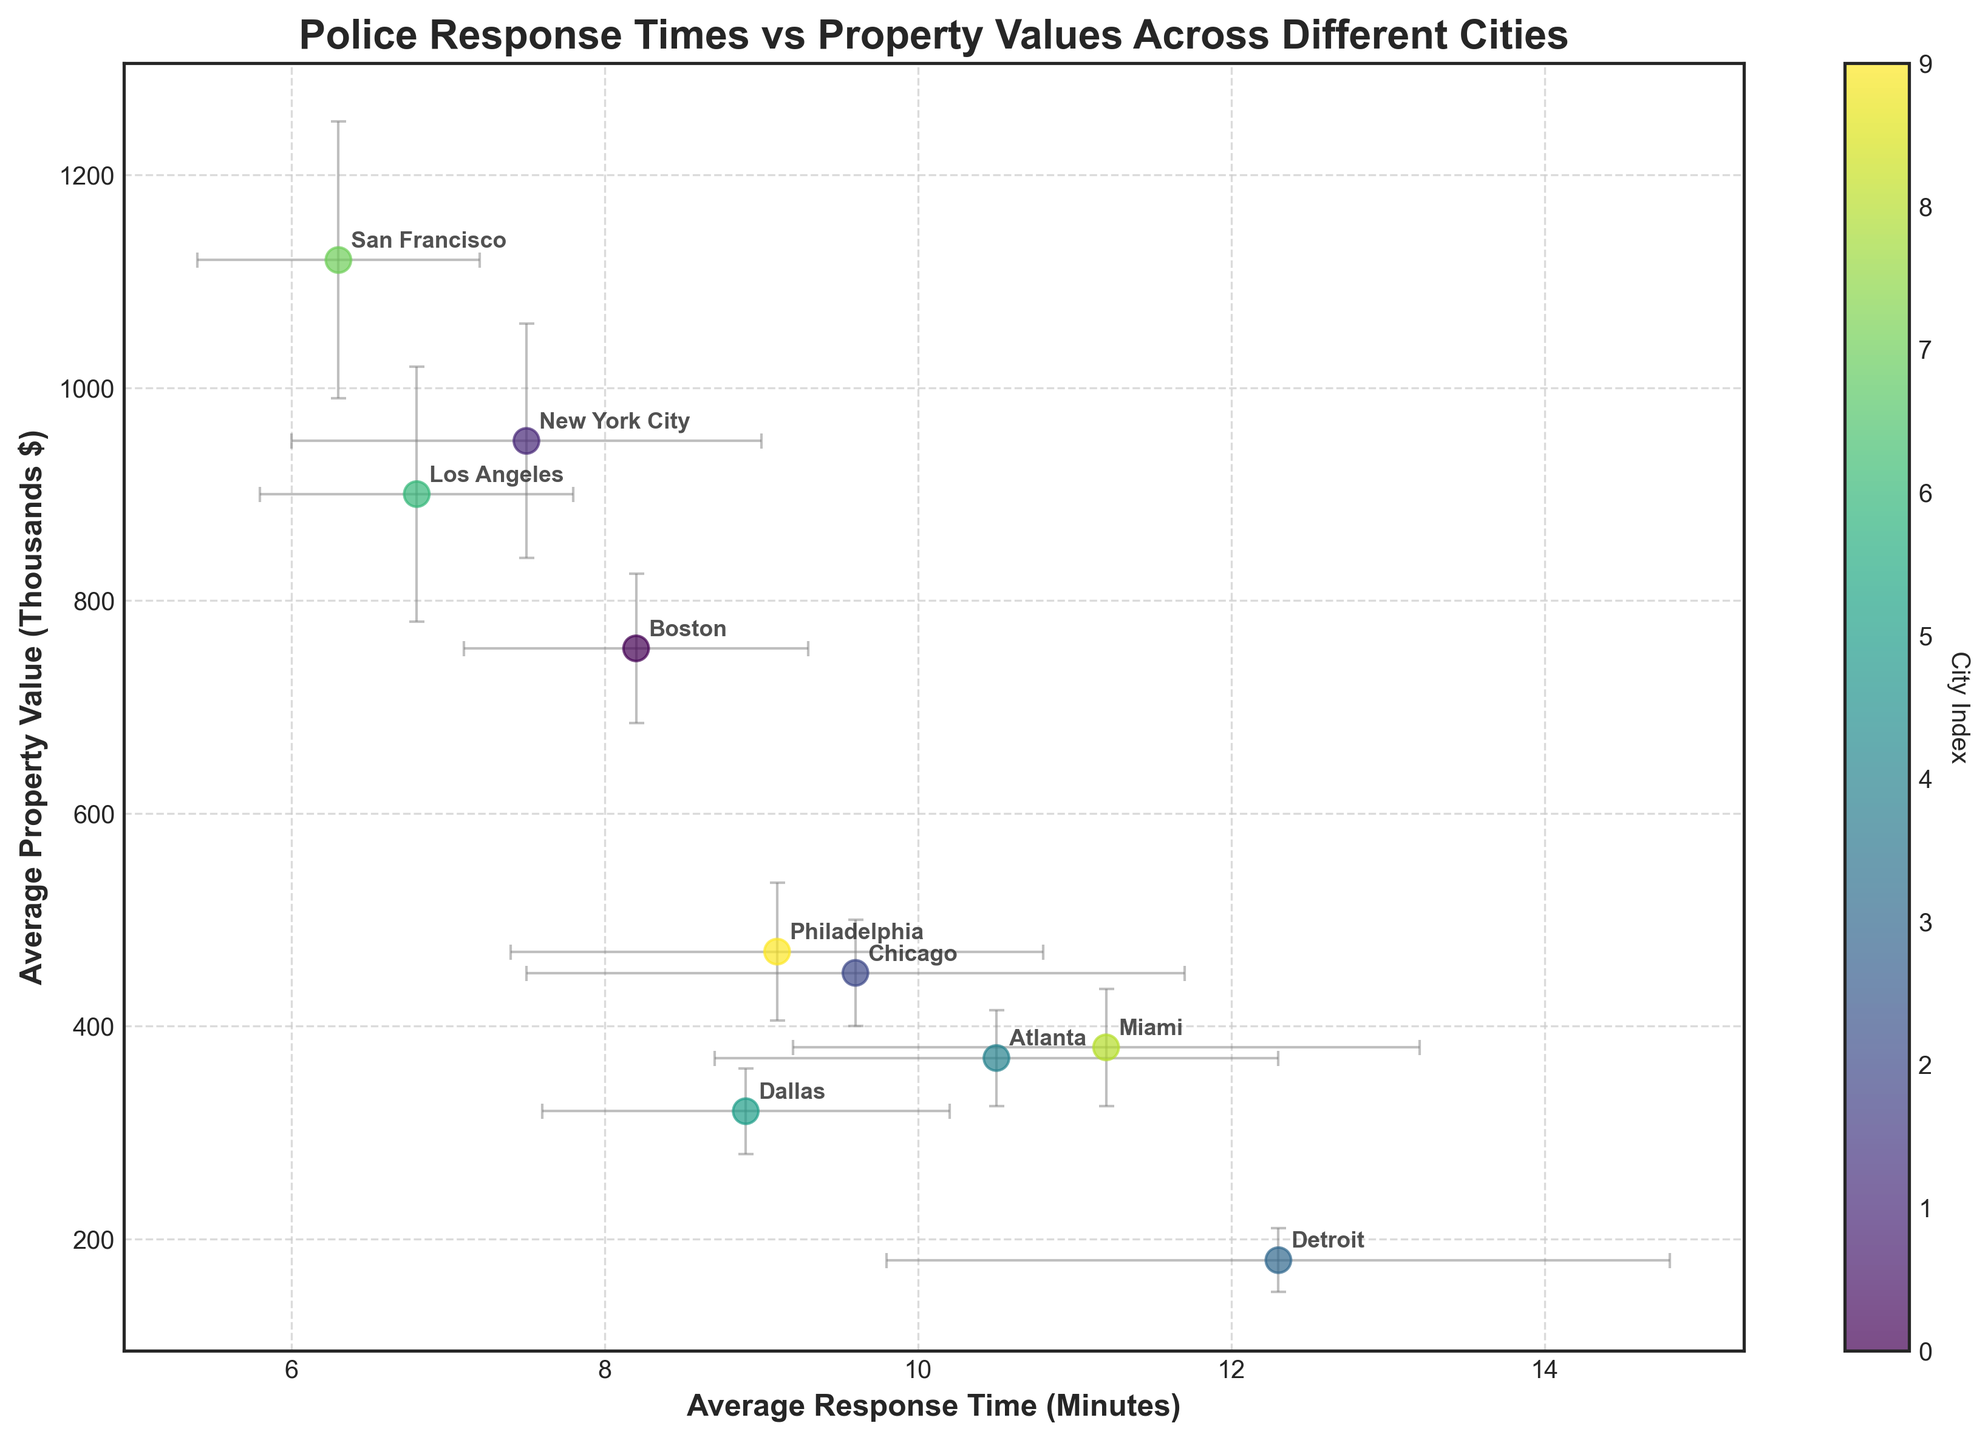How many cities are represented in the figure? There are several cities plotted on the graph. Count each unique labeled point.
Answer: 10 Which city has the lowest average police response time? Look for the city on the far left on the x-axis, indicating the lowest average response time.
Answer: San Francisco Which city has the highest average property value? Find the city plotted highest on the y-axis, representing the highest property value.
Answer: San Francisco What is the average response time for Los Angeles? Locate the point labeled Los Angeles and check its position on the x-axis.
Answer: 6.8 minutes Which cities have an average response time of less than 8 minutes? Identify the cities whose points are to the left of the 8-minute mark on the x-axis.
Answer: New York City, Los Angeles, and San Francisco How does the response time of Chicago compare to the response time of Detroit? Find the points for Chicago and Detroit and compare their positions on the x-axis. Chicago is to the left of Detroit, implying a shorter response time.
Answer: Chicago has a shorter response time What is the range of average property values across all cities? Determine the highest and lowest points on the y-axis and calculate the difference. The highest value is 1120 (San Francisco), and the lowest is 180 (Detroit). The range is 1120 - 180 = 940.
Answer: 940 Which city is represented with the highest variance in property values? Look at the lengths of the error bars on the y-axis and find the city with the largest bar.
Answer: San Francisco What is the average property value for cities in the Northeast region? Focus on cities in the Northeast region (Boston, New York City, Philadelphia) and calculate their average property value. (755 + 950 + 470) / 3 = 725
Answer: 725 Are there any cities with an average response time greater than 10 minutes? If so, which ones? Identify the points on the x-axis with a value greater than 10 minutes; check the city labels.
Answer: Detroit, Atlanta, Miami 